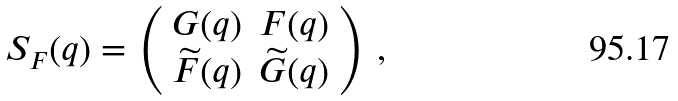<formula> <loc_0><loc_0><loc_500><loc_500>S _ { F } ( q ) = \left ( \begin{array} { l l } G ( q ) & F ( q ) \\ \widetilde { F } ( q ) & \widetilde { G } ( q ) \end{array} \right ) \, ,</formula> 